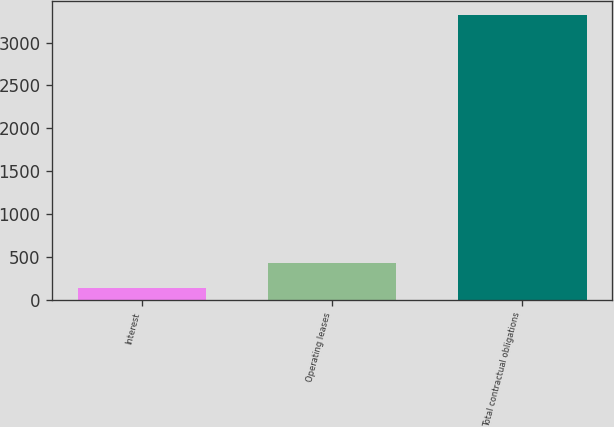<chart> <loc_0><loc_0><loc_500><loc_500><bar_chart><fcel>Interest<fcel>Operating leases<fcel>Total contractual obligations<nl><fcel>137<fcel>426.2<fcel>3318.2<nl></chart> 